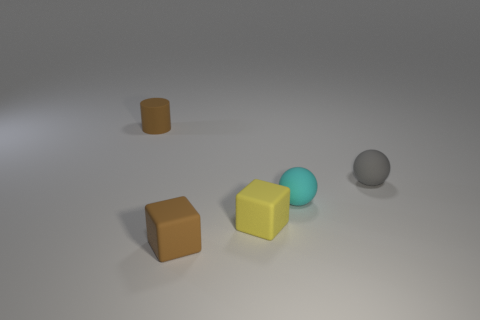Add 4 tiny cyan cylinders. How many objects exist? 9 Subtract all brown blocks. How many blocks are left? 1 Subtract all brown balls. How many green cylinders are left? 0 Subtract all balls. How many objects are left? 3 Subtract 1 blocks. How many blocks are left? 1 Subtract all yellow cylinders. Subtract all green cubes. How many cylinders are left? 1 Subtract all big purple rubber blocks. Subtract all tiny brown matte cubes. How many objects are left? 4 Add 3 blocks. How many blocks are left? 5 Add 1 brown blocks. How many brown blocks exist? 2 Subtract 1 yellow cubes. How many objects are left? 4 